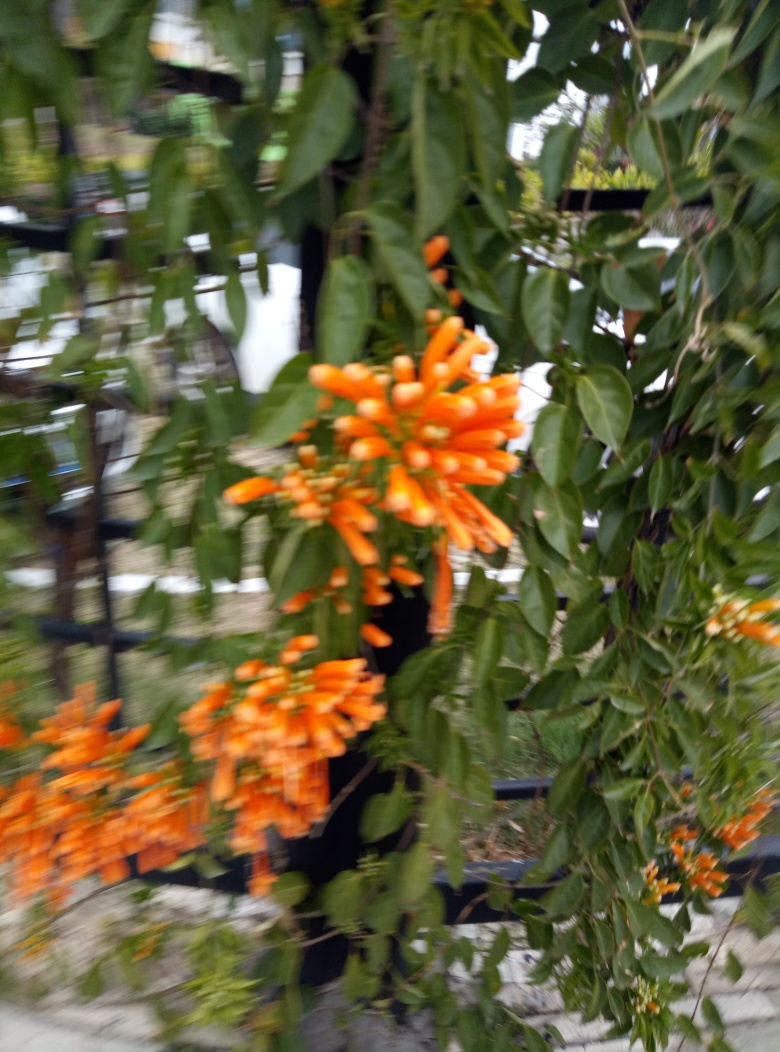Could you describe the ideal growing conditions for these flowers? These flowers thrive in bright sunlight and prefer well-draining soil. They're drought-tolerant once established but benefit from regular watering during the flowering season. A warm climate is essential, as they do not tolerate frost. What are their maintenance requirements? Maintenance includes providing support structures for climbing, pruning to control growth, and removing any damaged or diseased portions to keep the plant healthy. They might also require occasional fertilization for optimal blooming. 